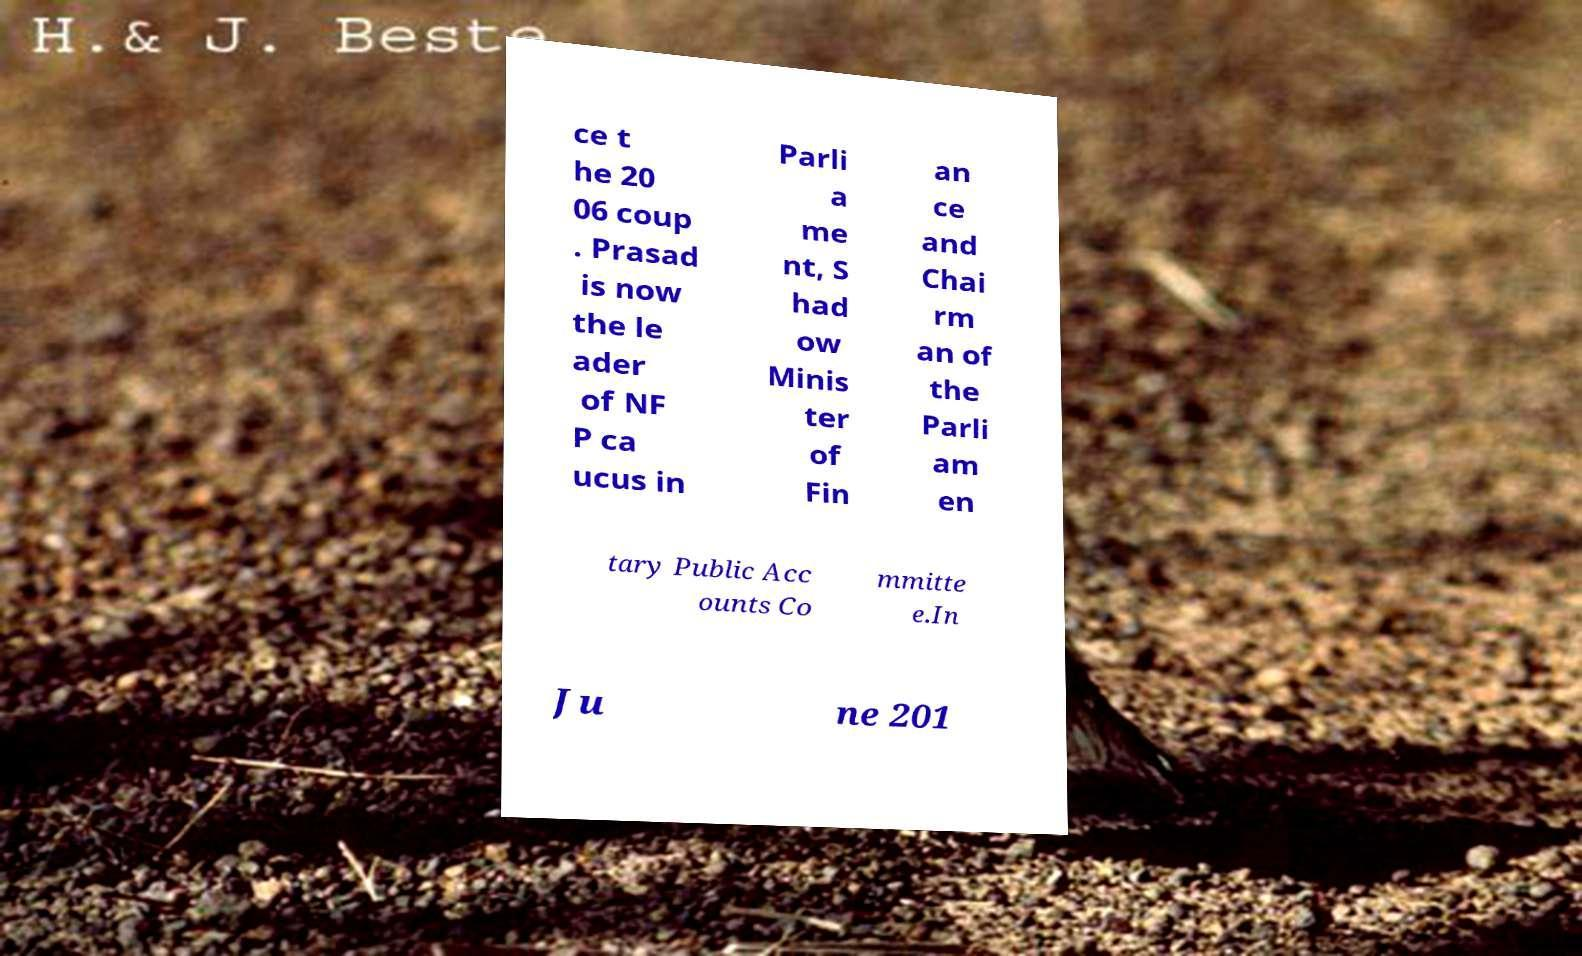Could you extract and type out the text from this image? ce t he 20 06 coup . Prasad is now the le ader of NF P ca ucus in Parli a me nt, S had ow Minis ter of Fin an ce and Chai rm an of the Parli am en tary Public Acc ounts Co mmitte e.In Ju ne 201 